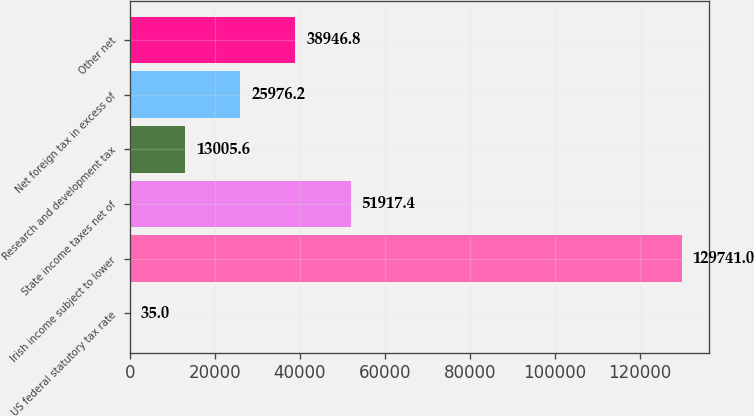Convert chart. <chart><loc_0><loc_0><loc_500><loc_500><bar_chart><fcel>US federal statutory tax rate<fcel>Irish income subject to lower<fcel>State income taxes net of<fcel>Research and development tax<fcel>Net foreign tax in excess of<fcel>Other net<nl><fcel>35<fcel>129741<fcel>51917.4<fcel>13005.6<fcel>25976.2<fcel>38946.8<nl></chart> 